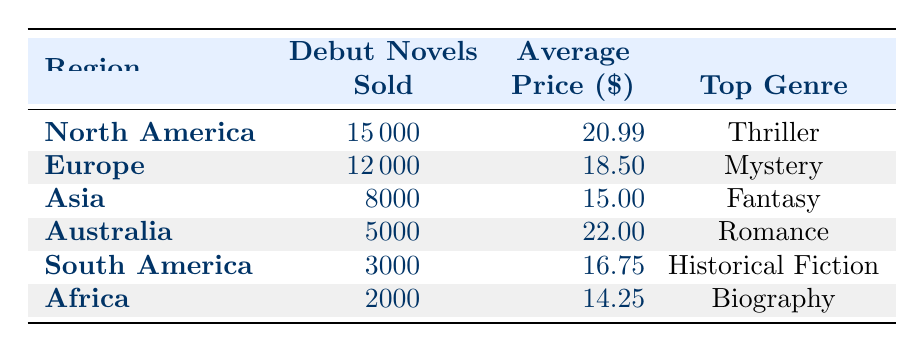What is the top genre in North America? The table shows that the top genre in North America is listed in the "Top Genre" column corresponding to that region, which is Thriller.
Answer: Thriller How many debut novels were sold in Europe? The value for debut novels sold in Europe can be found directly in the table under the "Debut Novels Sold" column for Europe, which shows 12000.
Answer: 12000 What is the average price of debut novels sold in Asia? The average price for debut novels in Asia is found in the "Average Price" column under the Asia row, which is 15.00.
Answer: 15.00 Which region has the lowest sales of debut novels? By comparing the values in the "Debut Novels Sold" column, Africa has the lowest with a total of 2000.
Answer: Africa What is the total number of debut novels sold across all regions? To find the total, we add the debut novels sold for all regions: 15000 + 12000 + 8000 + 5000 + 3000 + 2000 = 40000.
Answer: 40000 Is the average price of debut novels in Europe lower than that in North America? By checking the "Average Price" values, Europe has an average price of 18.50 and North America has 20.99. Since 18.50 is less than 20.99, the statement is true.
Answer: Yes Which region sells more debut novels, Australia or South America? The table shows that Australia sold 5000 debut novels and South America sold 3000. Since 5000 is greater than 3000, Australia sells more.
Answer: Australia Calculate the average price of debut novels sold in all regions. To find the average price, we sum the prices: (20.99 + 18.50 + 15.00 + 22.00 + 16.75 + 14.25) = 107.49 and divide by the number of regions (6), giving an average price of 17.915.
Answer: 17.915 Is the majority of debut novels sold in the thriller genre? North America, which is the highest selling region with 15000, has Thriller as its top genre, but other regions have different top genres. The total thriller sales can’t be found without looking at other regions, thus we cannot confirm that thriller is a majority genre.
Answer: No 